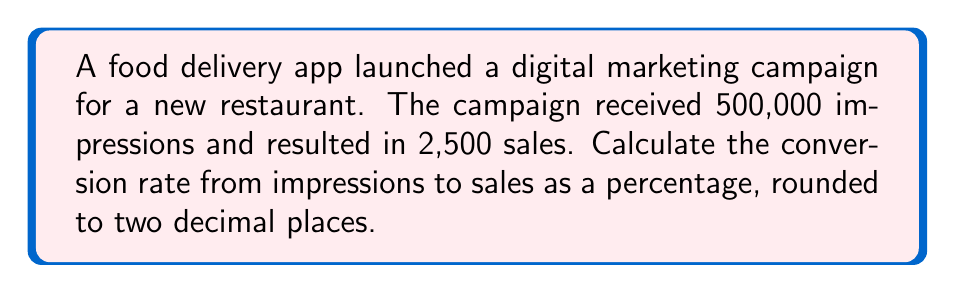Provide a solution to this math problem. To calculate the conversion rate from impressions to sales, we need to follow these steps:

1. Identify the given information:
   - Number of impressions: 500,000
   - Number of sales: 2,500

2. Set up the ratio of sales to impressions:
   $$\text{Conversion Rate} = \frac{\text{Number of Sales}}{\text{Number of Impressions}}$$

3. Substitute the values:
   $$\text{Conversion Rate} = \frac{2,500}{500,000}$$

4. Simplify the fraction:
   $$\text{Conversion Rate} = \frac{1}{200} = 0.005$$

5. Convert the decimal to a percentage by multiplying by 100:
   $$\text{Conversion Rate} = 0.005 \times 100 = 0.5\%$$

6. Round to two decimal places:
   The result is already in two decimal places, so no further rounding is needed.

Therefore, the conversion rate from impressions to sales is 0.5%.
Answer: 0.5% 